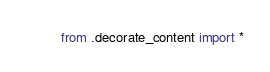Convert code to text. <code><loc_0><loc_0><loc_500><loc_500><_Python_>from .decorate_content import *
</code> 